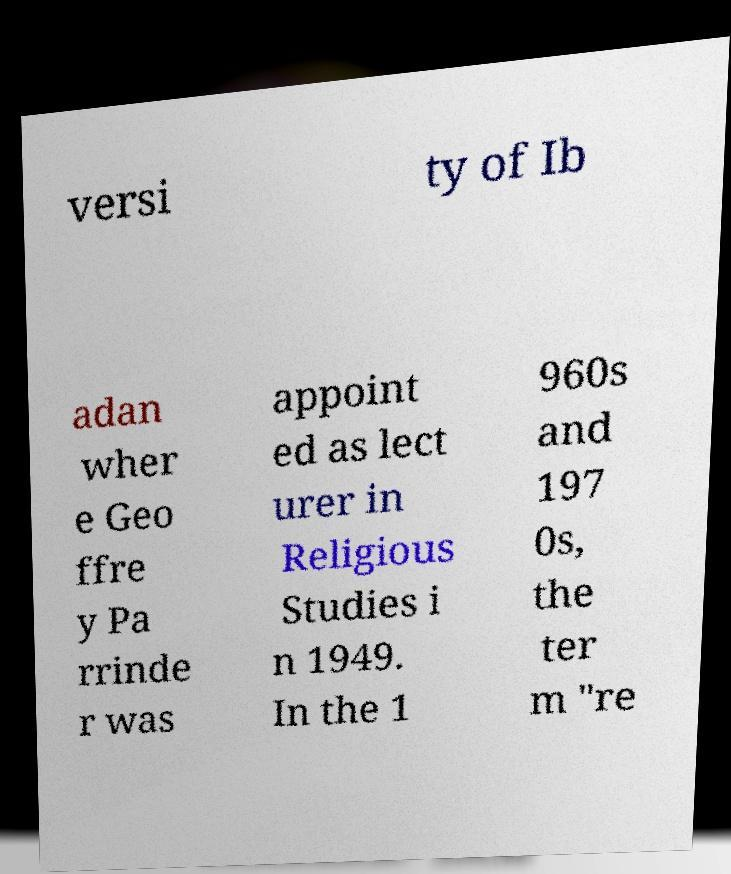I need the written content from this picture converted into text. Can you do that? versi ty of Ib adan wher e Geo ffre y Pa rrinde r was appoint ed as lect urer in Religious Studies i n 1949. In the 1 960s and 197 0s, the ter m "re 